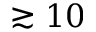<formula> <loc_0><loc_0><loc_500><loc_500>\gtrsim 1 0</formula> 